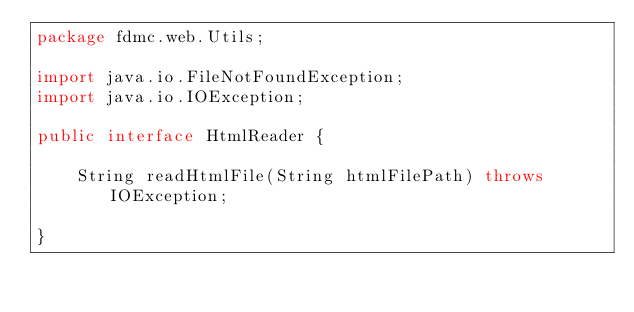<code> <loc_0><loc_0><loc_500><loc_500><_Java_>package fdmc.web.Utils;

import java.io.FileNotFoundException;
import java.io.IOException;

public interface HtmlReader {

    String readHtmlFile(String htmlFilePath) throws IOException;

}
</code> 